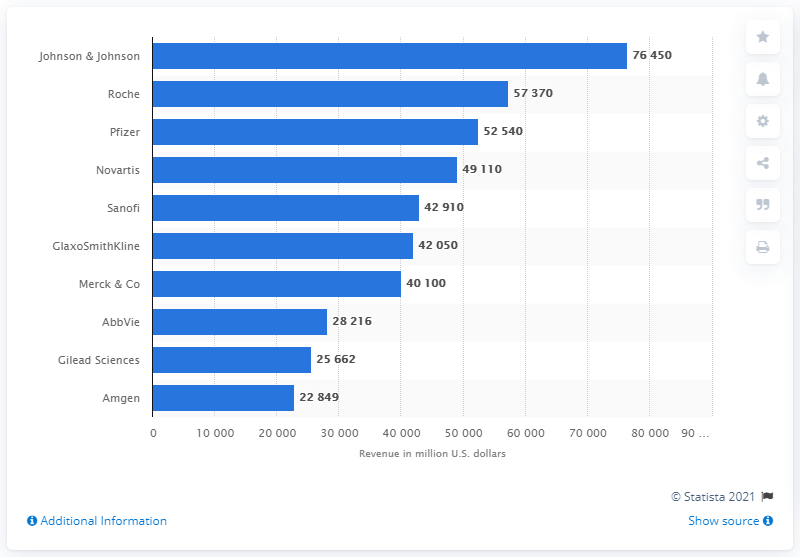Draw attention to some important aspects in this diagram. Johnson & Johnson generated approximately 76,450 million dollars in revenue in 2017. 